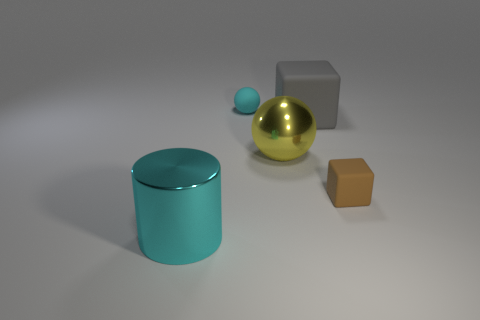The thing that is the same color as the metal cylinder is what shape?
Ensure brevity in your answer.  Sphere. What number of large metallic objects are behind the metal thing to the right of the cyan thing behind the cyan cylinder?
Offer a very short reply. 0. There is a cyan thing that is in front of the metallic thing on the right side of the large cyan shiny cylinder; how big is it?
Provide a succinct answer. Large. What size is the other cube that is made of the same material as the brown block?
Your answer should be very brief. Large. There is a big thing that is left of the gray object and behind the metallic cylinder; what is its shape?
Your response must be concise. Sphere. Is the number of large yellow objects that are on the left side of the brown block the same as the number of big red cylinders?
Your answer should be very brief. No. How many things are either large metallic cylinders or small rubber objects behind the big gray cube?
Provide a succinct answer. 2. Are there any other tiny matte objects that have the same shape as the gray rubber object?
Keep it short and to the point. Yes. Are there an equal number of large cyan shiny cylinders that are to the right of the large gray object and large things right of the brown rubber object?
Ensure brevity in your answer.  Yes. How many green things are matte things or big shiny cylinders?
Offer a very short reply. 0. 